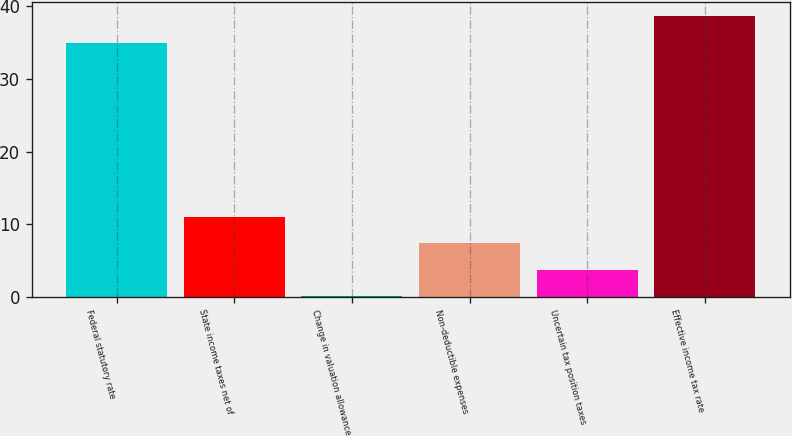Convert chart to OTSL. <chart><loc_0><loc_0><loc_500><loc_500><bar_chart><fcel>Federal statutory rate<fcel>State income taxes net of<fcel>Change in valuation allowance<fcel>Non-deductible expenses<fcel>Uncertain tax position taxes<fcel>Effective income tax rate<nl><fcel>35<fcel>11.02<fcel>0.1<fcel>7.38<fcel>3.74<fcel>38.64<nl></chart> 